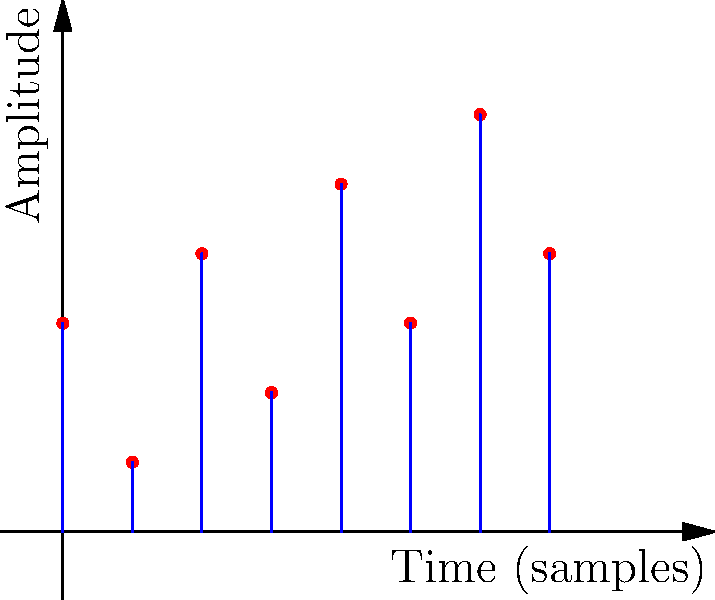Given the digital signal representation shown in the figure, determine:
a) The sampling rate if the time between two consecutive samples is 0.25 seconds.
b) The number of quantization levels used to represent the signal amplitudes. Let's approach this step-by-step:

a) To find the sampling rate:
   1. The sampling rate is the number of samples taken per second.
   2. We're given that the time between two consecutive samples is 0.25 seconds.
   3. To find samples per second, we need to take the inverse of this time:
      $f_s = \frac{1}{0.25\text{ s}} = 4\text{ Hz}$

b) To determine the number of quantization levels:
   1. Look at the amplitude values in the graph.
   2. The amplitudes are represented by integer values.
   3. The minimum amplitude is 1, and the maximum is 6.
   4. Count the number of distinct amplitude values: 1, 2, 3, 4, 5, 6
   5. There are 6 distinct levels.

Therefore, the signal uses 6 quantization levels.
Answer: a) 4 Hz
b) 6 levels 